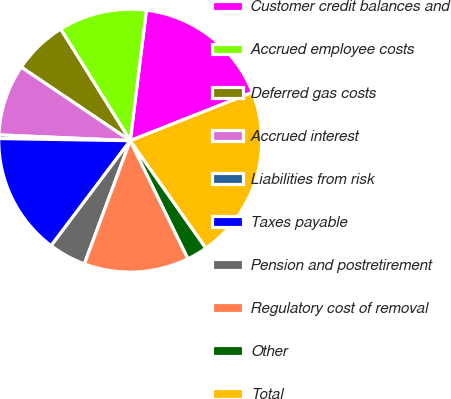Convert chart. <chart><loc_0><loc_0><loc_500><loc_500><pie_chart><fcel>Customer credit balances and<fcel>Accrued employee costs<fcel>Deferred gas costs<fcel>Accrued interest<fcel>Liabilities from risk<fcel>Taxes payable<fcel>Pension and postretirement<fcel>Regulatory cost of removal<fcel>Other<fcel>Total<nl><fcel>17.06%<fcel>10.83%<fcel>6.68%<fcel>8.75%<fcel>0.44%<fcel>14.99%<fcel>4.6%<fcel>12.91%<fcel>2.52%<fcel>21.22%<nl></chart> 